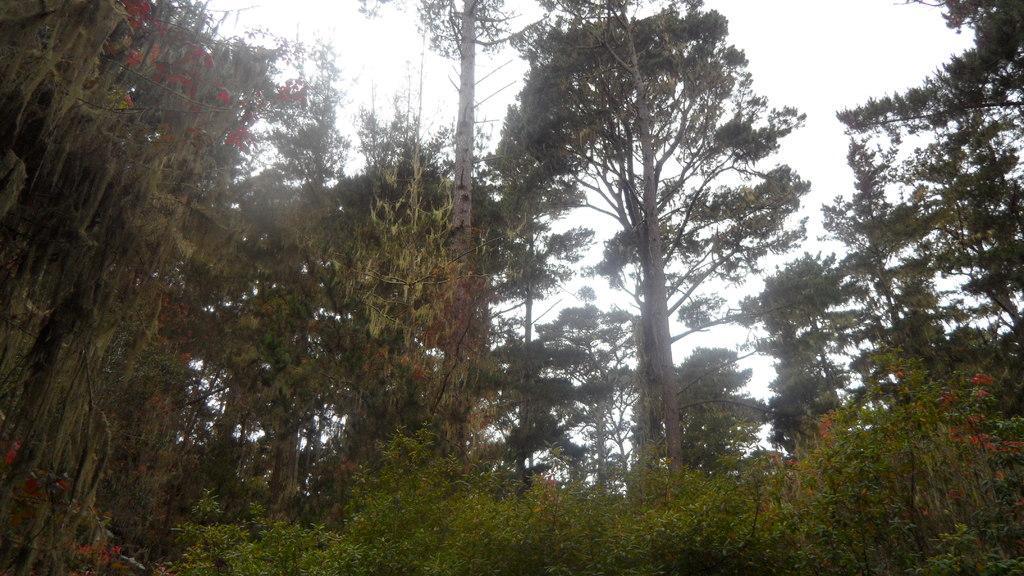Could you give a brief overview of what you see in this image? In this picture we can see the trees and flowers. At the top of the image we can see the sky. 